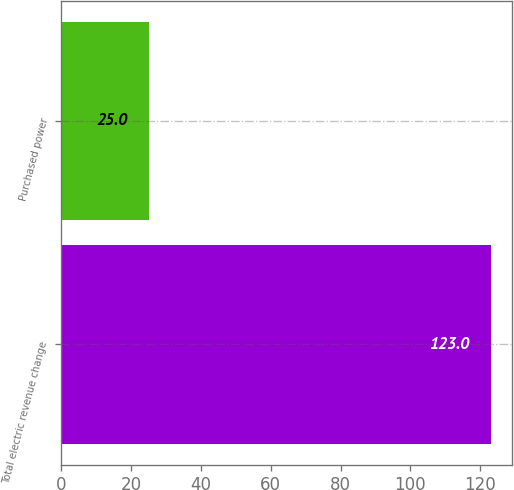<chart> <loc_0><loc_0><loc_500><loc_500><bar_chart><fcel>Total electric revenue change<fcel>Purchased power<nl><fcel>123<fcel>25<nl></chart> 